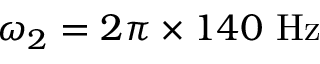Convert formula to latex. <formula><loc_0><loc_0><loc_500><loc_500>\omega _ { 2 } = 2 \pi \times 1 4 0 H z</formula> 